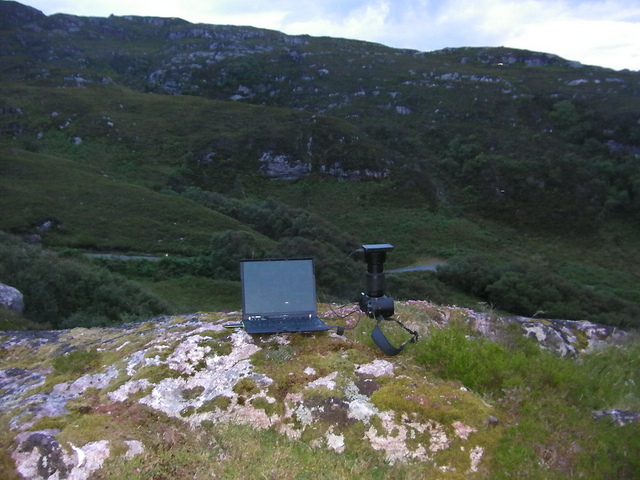<image>Is there electricity here? I am not sure. It can be both 'yes' and 'no'. Is there electricity here? I am not sure if there is electricity here. It can be both yes or no. 